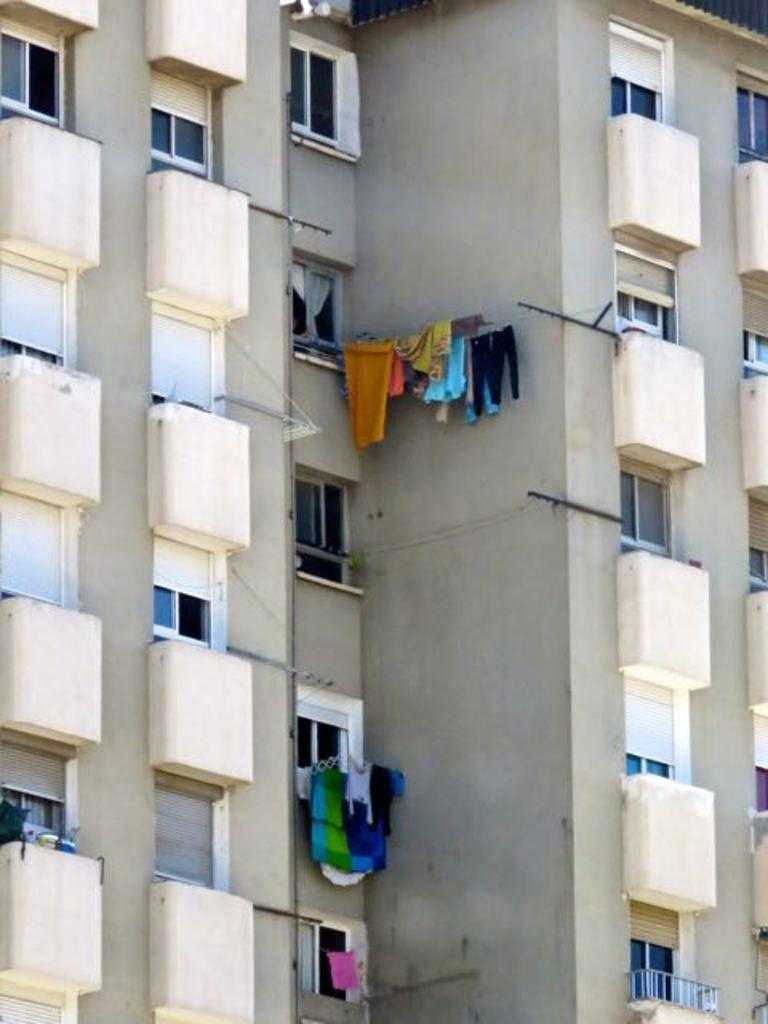What type of structures can be seen in the picture? There are buildings in the picture. What can be found hanging in the image? Clothes are hanged in the image. What type of windows are present in the image? There are glass windows in the image. What architectural feature is visible in the image? There is a balcony in the image. How does the comb help in the image? There is no comb present in the image, so it cannot help in any way. 